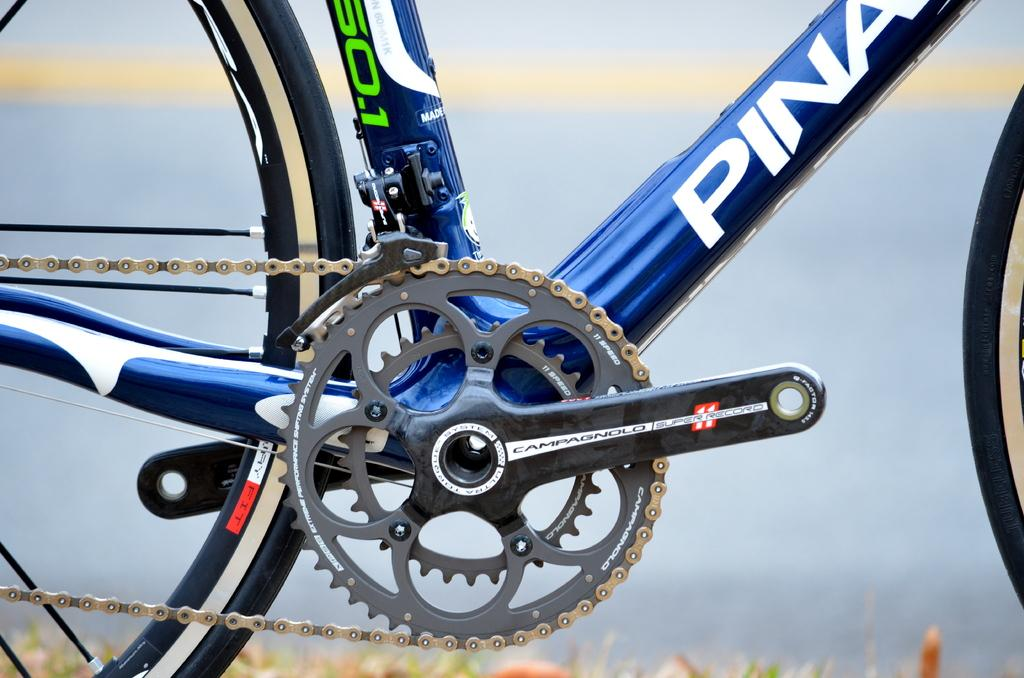What is the main object in the image? There is a bicycle in the image. Can you describe the position of the bicycle? The bicycle is on the ground. What can be seen in the background of the image? The sky is visible in the background of the image. What type of government is depicted in the image? There is no government depicted in the image; it features a bicycle on the ground with the sky in the background. What kind of stitch is used to create the bicycle in the image? The image is not a drawing or a fabric, so there is no stitching involved in its creation. 